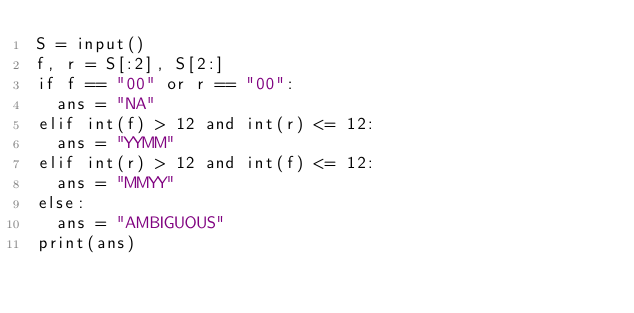Convert code to text. <code><loc_0><loc_0><loc_500><loc_500><_Python_>S = input()
f, r = S[:2], S[2:]
if f == "00" or r == "00":
  ans = "NA"
elif int(f) > 12 and int(r) <= 12:
  ans = "YYMM"
elif int(r) > 12 and int(f) <= 12:
  ans = "MMYY"
else:
  ans = "AMBIGUOUS"
print(ans)</code> 